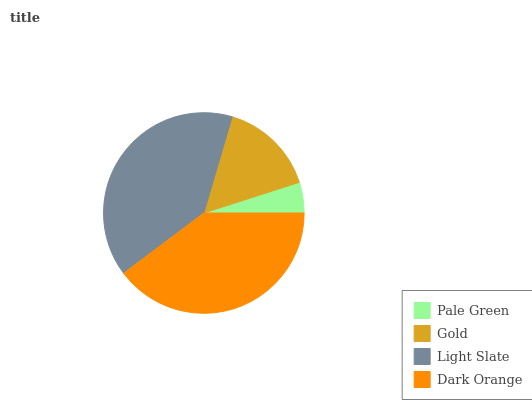Is Pale Green the minimum?
Answer yes or no. Yes. Is Light Slate the maximum?
Answer yes or no. Yes. Is Gold the minimum?
Answer yes or no. No. Is Gold the maximum?
Answer yes or no. No. Is Gold greater than Pale Green?
Answer yes or no. Yes. Is Pale Green less than Gold?
Answer yes or no. Yes. Is Pale Green greater than Gold?
Answer yes or no. No. Is Gold less than Pale Green?
Answer yes or no. No. Is Dark Orange the high median?
Answer yes or no. Yes. Is Gold the low median?
Answer yes or no. Yes. Is Light Slate the high median?
Answer yes or no. No. Is Light Slate the low median?
Answer yes or no. No. 